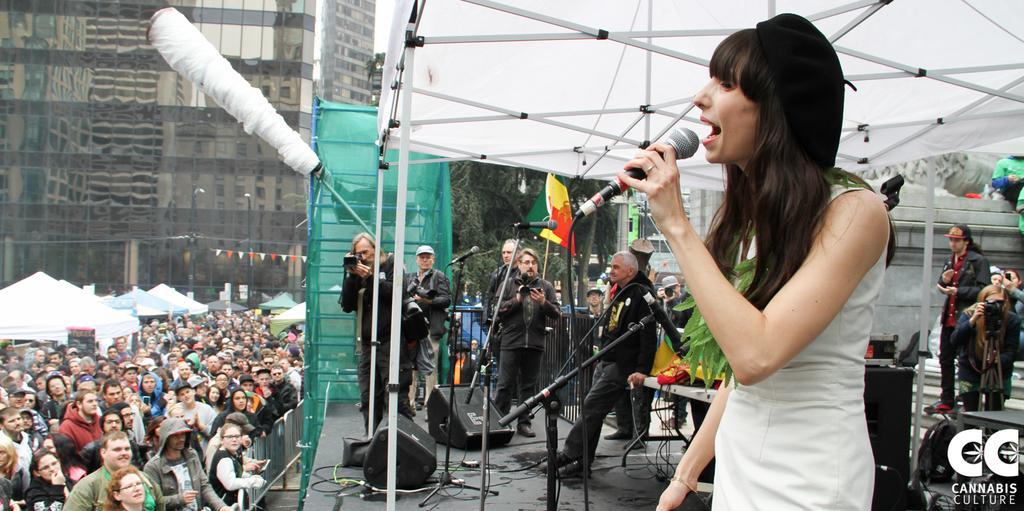Please provide a concise description of this image. In this image there is a woman standing and holding a micro phone and in back ground there are group of people, tent ,building ,speaker , piano , tree , flag. 